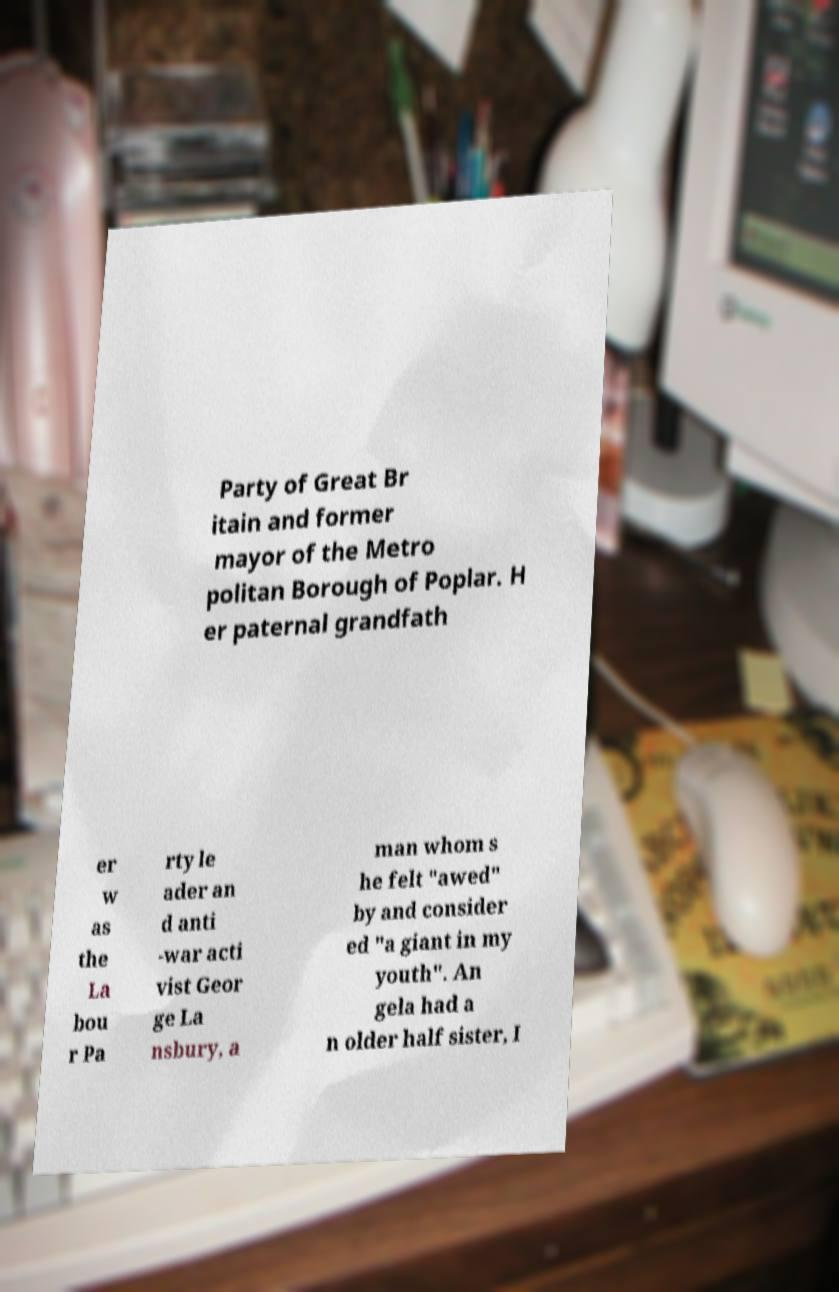Could you extract and type out the text from this image? Party of Great Br itain and former mayor of the Metro politan Borough of Poplar. H er paternal grandfath er w as the La bou r Pa rty le ader an d anti -war acti vist Geor ge La nsbury, a man whom s he felt "awed" by and consider ed "a giant in my youth". An gela had a n older half sister, I 